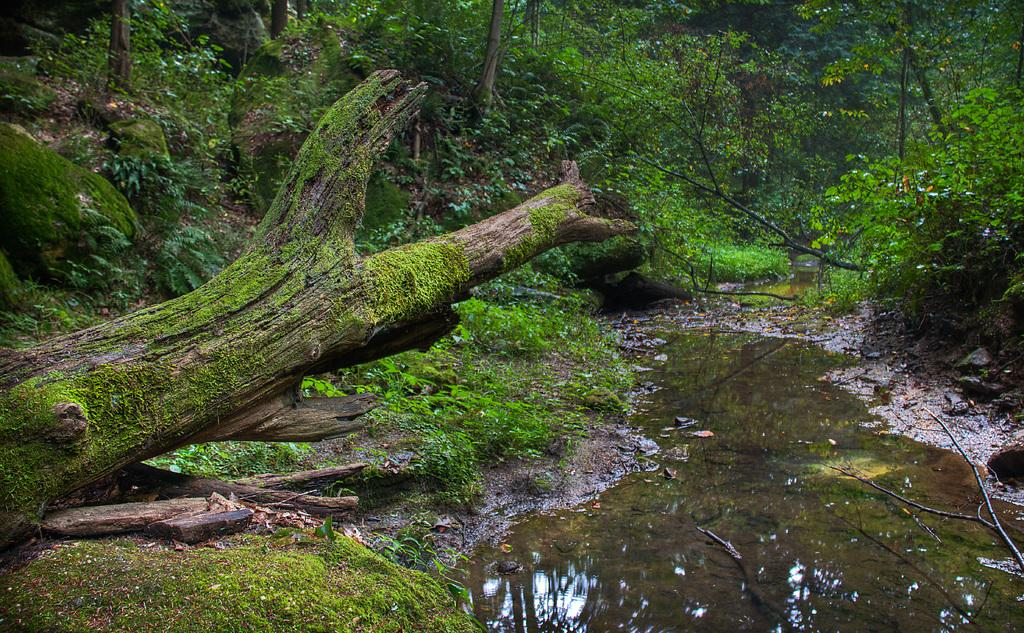What natural element can be seen in the image? Water is visible in the image. What type of vegetation can be seen in the image? There are branches, grass, and trees visible in the image. Where is the advertisement for a chance to win a hand in the image? There is no advertisement or mention of a hand or a chance to win anything in the image. 